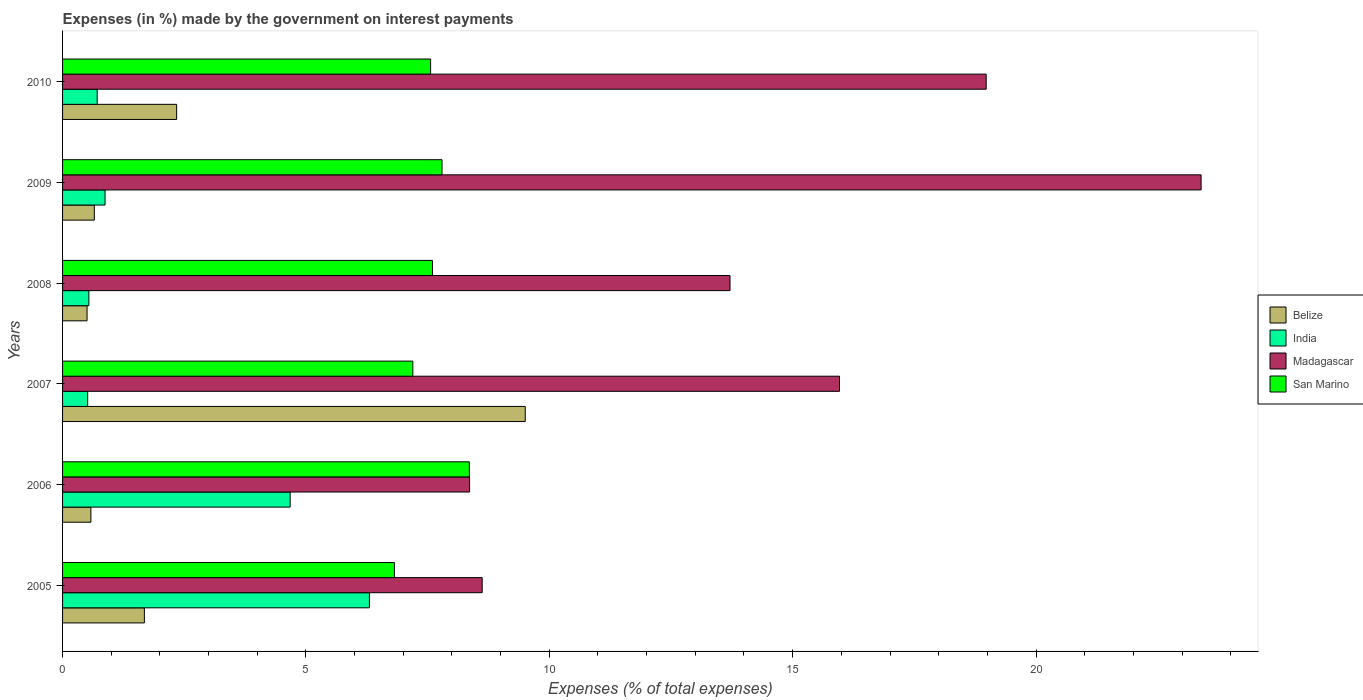How many different coloured bars are there?
Ensure brevity in your answer.  4. How many groups of bars are there?
Make the answer very short. 6. How many bars are there on the 3rd tick from the top?
Offer a very short reply. 4. How many bars are there on the 4th tick from the bottom?
Your answer should be very brief. 4. What is the percentage of expenses made by the government on interest payments in Belize in 2007?
Give a very brief answer. 9.51. Across all years, what is the maximum percentage of expenses made by the government on interest payments in Belize?
Provide a short and direct response. 9.51. Across all years, what is the minimum percentage of expenses made by the government on interest payments in San Marino?
Offer a very short reply. 6.82. In which year was the percentage of expenses made by the government on interest payments in India maximum?
Provide a succinct answer. 2005. What is the total percentage of expenses made by the government on interest payments in Belize in the graph?
Make the answer very short. 15.27. What is the difference between the percentage of expenses made by the government on interest payments in Madagascar in 2005 and that in 2010?
Make the answer very short. -10.36. What is the difference between the percentage of expenses made by the government on interest payments in India in 2005 and the percentage of expenses made by the government on interest payments in San Marino in 2009?
Keep it short and to the point. -1.49. What is the average percentage of expenses made by the government on interest payments in Madagascar per year?
Provide a short and direct response. 14.84. In the year 2006, what is the difference between the percentage of expenses made by the government on interest payments in Madagascar and percentage of expenses made by the government on interest payments in Belize?
Provide a short and direct response. 7.78. In how many years, is the percentage of expenses made by the government on interest payments in Belize greater than 4 %?
Give a very brief answer. 1. What is the ratio of the percentage of expenses made by the government on interest payments in San Marino in 2005 to that in 2010?
Offer a terse response. 0.9. Is the percentage of expenses made by the government on interest payments in India in 2006 less than that in 2008?
Your answer should be very brief. No. What is the difference between the highest and the second highest percentage of expenses made by the government on interest payments in India?
Offer a very short reply. 1.63. What is the difference between the highest and the lowest percentage of expenses made by the government on interest payments in India?
Give a very brief answer. 5.79. In how many years, is the percentage of expenses made by the government on interest payments in San Marino greater than the average percentage of expenses made by the government on interest payments in San Marino taken over all years?
Provide a short and direct response. 4. What does the 1st bar from the top in 2005 represents?
Make the answer very short. San Marino. Is it the case that in every year, the sum of the percentage of expenses made by the government on interest payments in San Marino and percentage of expenses made by the government on interest payments in Belize is greater than the percentage of expenses made by the government on interest payments in Madagascar?
Your answer should be very brief. No. Are all the bars in the graph horizontal?
Keep it short and to the point. Yes. How many years are there in the graph?
Offer a very short reply. 6. What is the difference between two consecutive major ticks on the X-axis?
Make the answer very short. 5. Are the values on the major ticks of X-axis written in scientific E-notation?
Give a very brief answer. No. Does the graph contain grids?
Your response must be concise. No. How many legend labels are there?
Provide a short and direct response. 4. What is the title of the graph?
Provide a short and direct response. Expenses (in %) made by the government on interest payments. What is the label or title of the X-axis?
Keep it short and to the point. Expenses (% of total expenses). What is the Expenses (% of total expenses) in Belize in 2005?
Offer a terse response. 1.68. What is the Expenses (% of total expenses) in India in 2005?
Make the answer very short. 6.3. What is the Expenses (% of total expenses) of Madagascar in 2005?
Make the answer very short. 8.62. What is the Expenses (% of total expenses) of San Marino in 2005?
Make the answer very short. 6.82. What is the Expenses (% of total expenses) in Belize in 2006?
Offer a terse response. 0.58. What is the Expenses (% of total expenses) of India in 2006?
Your answer should be very brief. 4.68. What is the Expenses (% of total expenses) of Madagascar in 2006?
Provide a short and direct response. 8.36. What is the Expenses (% of total expenses) in San Marino in 2006?
Offer a terse response. 8.36. What is the Expenses (% of total expenses) of Belize in 2007?
Give a very brief answer. 9.51. What is the Expenses (% of total expenses) of India in 2007?
Offer a terse response. 0.52. What is the Expenses (% of total expenses) of Madagascar in 2007?
Make the answer very short. 15.96. What is the Expenses (% of total expenses) of San Marino in 2007?
Your answer should be compact. 7.2. What is the Expenses (% of total expenses) in Belize in 2008?
Your answer should be very brief. 0.5. What is the Expenses (% of total expenses) in India in 2008?
Offer a very short reply. 0.54. What is the Expenses (% of total expenses) in Madagascar in 2008?
Your response must be concise. 13.71. What is the Expenses (% of total expenses) of San Marino in 2008?
Provide a succinct answer. 7.6. What is the Expenses (% of total expenses) of Belize in 2009?
Ensure brevity in your answer.  0.65. What is the Expenses (% of total expenses) in India in 2009?
Ensure brevity in your answer.  0.87. What is the Expenses (% of total expenses) of Madagascar in 2009?
Provide a succinct answer. 23.39. What is the Expenses (% of total expenses) of San Marino in 2009?
Offer a very short reply. 7.8. What is the Expenses (% of total expenses) in Belize in 2010?
Provide a succinct answer. 2.34. What is the Expenses (% of total expenses) in India in 2010?
Provide a short and direct response. 0.71. What is the Expenses (% of total expenses) in Madagascar in 2010?
Provide a succinct answer. 18.98. What is the Expenses (% of total expenses) in San Marino in 2010?
Keep it short and to the point. 7.56. Across all years, what is the maximum Expenses (% of total expenses) in Belize?
Give a very brief answer. 9.51. Across all years, what is the maximum Expenses (% of total expenses) in India?
Give a very brief answer. 6.3. Across all years, what is the maximum Expenses (% of total expenses) in Madagascar?
Make the answer very short. 23.39. Across all years, what is the maximum Expenses (% of total expenses) in San Marino?
Provide a short and direct response. 8.36. Across all years, what is the minimum Expenses (% of total expenses) in Belize?
Offer a very short reply. 0.5. Across all years, what is the minimum Expenses (% of total expenses) in India?
Your response must be concise. 0.52. Across all years, what is the minimum Expenses (% of total expenses) in Madagascar?
Offer a very short reply. 8.36. Across all years, what is the minimum Expenses (% of total expenses) in San Marino?
Your answer should be compact. 6.82. What is the total Expenses (% of total expenses) of Belize in the graph?
Provide a succinct answer. 15.27. What is the total Expenses (% of total expenses) in India in the graph?
Provide a short and direct response. 13.62. What is the total Expenses (% of total expenses) of Madagascar in the graph?
Make the answer very short. 89.03. What is the total Expenses (% of total expenses) in San Marino in the graph?
Ensure brevity in your answer.  45.33. What is the difference between the Expenses (% of total expenses) of Belize in 2005 and that in 2006?
Your answer should be compact. 1.1. What is the difference between the Expenses (% of total expenses) of India in 2005 and that in 2006?
Your response must be concise. 1.63. What is the difference between the Expenses (% of total expenses) of Madagascar in 2005 and that in 2006?
Offer a terse response. 0.26. What is the difference between the Expenses (% of total expenses) of San Marino in 2005 and that in 2006?
Ensure brevity in your answer.  -1.54. What is the difference between the Expenses (% of total expenses) in Belize in 2005 and that in 2007?
Offer a terse response. -7.83. What is the difference between the Expenses (% of total expenses) in India in 2005 and that in 2007?
Your answer should be compact. 5.79. What is the difference between the Expenses (% of total expenses) in Madagascar in 2005 and that in 2007?
Give a very brief answer. -7.34. What is the difference between the Expenses (% of total expenses) of San Marino in 2005 and that in 2007?
Offer a very short reply. -0.38. What is the difference between the Expenses (% of total expenses) of Belize in 2005 and that in 2008?
Provide a succinct answer. 1.18. What is the difference between the Expenses (% of total expenses) of India in 2005 and that in 2008?
Offer a very short reply. 5.76. What is the difference between the Expenses (% of total expenses) of Madagascar in 2005 and that in 2008?
Ensure brevity in your answer.  -5.09. What is the difference between the Expenses (% of total expenses) of San Marino in 2005 and that in 2008?
Your answer should be very brief. -0.78. What is the difference between the Expenses (% of total expenses) of Belize in 2005 and that in 2009?
Offer a terse response. 1.03. What is the difference between the Expenses (% of total expenses) of India in 2005 and that in 2009?
Provide a succinct answer. 5.43. What is the difference between the Expenses (% of total expenses) in Madagascar in 2005 and that in 2009?
Ensure brevity in your answer.  -14.77. What is the difference between the Expenses (% of total expenses) in San Marino in 2005 and that in 2009?
Provide a short and direct response. -0.98. What is the difference between the Expenses (% of total expenses) of Belize in 2005 and that in 2010?
Ensure brevity in your answer.  -0.66. What is the difference between the Expenses (% of total expenses) of India in 2005 and that in 2010?
Offer a terse response. 5.59. What is the difference between the Expenses (% of total expenses) in Madagascar in 2005 and that in 2010?
Ensure brevity in your answer.  -10.36. What is the difference between the Expenses (% of total expenses) in San Marino in 2005 and that in 2010?
Keep it short and to the point. -0.74. What is the difference between the Expenses (% of total expenses) of Belize in 2006 and that in 2007?
Your answer should be very brief. -8.92. What is the difference between the Expenses (% of total expenses) of India in 2006 and that in 2007?
Your answer should be very brief. 4.16. What is the difference between the Expenses (% of total expenses) of Madagascar in 2006 and that in 2007?
Offer a terse response. -7.6. What is the difference between the Expenses (% of total expenses) of San Marino in 2006 and that in 2007?
Make the answer very short. 1.16. What is the difference between the Expenses (% of total expenses) in Belize in 2006 and that in 2008?
Provide a succinct answer. 0.08. What is the difference between the Expenses (% of total expenses) of India in 2006 and that in 2008?
Ensure brevity in your answer.  4.14. What is the difference between the Expenses (% of total expenses) of Madagascar in 2006 and that in 2008?
Give a very brief answer. -5.35. What is the difference between the Expenses (% of total expenses) in San Marino in 2006 and that in 2008?
Your answer should be very brief. 0.76. What is the difference between the Expenses (% of total expenses) in Belize in 2006 and that in 2009?
Provide a succinct answer. -0.07. What is the difference between the Expenses (% of total expenses) of India in 2006 and that in 2009?
Your answer should be very brief. 3.8. What is the difference between the Expenses (% of total expenses) in Madagascar in 2006 and that in 2009?
Ensure brevity in your answer.  -15.03. What is the difference between the Expenses (% of total expenses) of San Marino in 2006 and that in 2009?
Your answer should be compact. 0.56. What is the difference between the Expenses (% of total expenses) in Belize in 2006 and that in 2010?
Your response must be concise. -1.76. What is the difference between the Expenses (% of total expenses) in India in 2006 and that in 2010?
Offer a terse response. 3.96. What is the difference between the Expenses (% of total expenses) in Madagascar in 2006 and that in 2010?
Provide a succinct answer. -10.61. What is the difference between the Expenses (% of total expenses) in San Marino in 2006 and that in 2010?
Your answer should be compact. 0.8. What is the difference between the Expenses (% of total expenses) of Belize in 2007 and that in 2008?
Give a very brief answer. 9. What is the difference between the Expenses (% of total expenses) of India in 2007 and that in 2008?
Your answer should be compact. -0.02. What is the difference between the Expenses (% of total expenses) in Madagascar in 2007 and that in 2008?
Offer a very short reply. 2.25. What is the difference between the Expenses (% of total expenses) of San Marino in 2007 and that in 2008?
Provide a succinct answer. -0.4. What is the difference between the Expenses (% of total expenses) in Belize in 2007 and that in 2009?
Your response must be concise. 8.85. What is the difference between the Expenses (% of total expenses) in India in 2007 and that in 2009?
Ensure brevity in your answer.  -0.36. What is the difference between the Expenses (% of total expenses) in Madagascar in 2007 and that in 2009?
Ensure brevity in your answer.  -7.43. What is the difference between the Expenses (% of total expenses) in San Marino in 2007 and that in 2009?
Offer a very short reply. -0.6. What is the difference between the Expenses (% of total expenses) in Belize in 2007 and that in 2010?
Offer a very short reply. 7.16. What is the difference between the Expenses (% of total expenses) of India in 2007 and that in 2010?
Ensure brevity in your answer.  -0.2. What is the difference between the Expenses (% of total expenses) of Madagascar in 2007 and that in 2010?
Offer a terse response. -3.01. What is the difference between the Expenses (% of total expenses) in San Marino in 2007 and that in 2010?
Keep it short and to the point. -0.37. What is the difference between the Expenses (% of total expenses) of Belize in 2008 and that in 2009?
Keep it short and to the point. -0.15. What is the difference between the Expenses (% of total expenses) of India in 2008 and that in 2009?
Your answer should be very brief. -0.33. What is the difference between the Expenses (% of total expenses) of Madagascar in 2008 and that in 2009?
Offer a terse response. -9.68. What is the difference between the Expenses (% of total expenses) of San Marino in 2008 and that in 2009?
Offer a terse response. -0.2. What is the difference between the Expenses (% of total expenses) of Belize in 2008 and that in 2010?
Keep it short and to the point. -1.84. What is the difference between the Expenses (% of total expenses) of India in 2008 and that in 2010?
Your answer should be compact. -0.17. What is the difference between the Expenses (% of total expenses) in Madagascar in 2008 and that in 2010?
Your answer should be very brief. -5.26. What is the difference between the Expenses (% of total expenses) of San Marino in 2008 and that in 2010?
Offer a very short reply. 0.04. What is the difference between the Expenses (% of total expenses) in Belize in 2009 and that in 2010?
Give a very brief answer. -1.69. What is the difference between the Expenses (% of total expenses) of India in 2009 and that in 2010?
Ensure brevity in your answer.  0.16. What is the difference between the Expenses (% of total expenses) of Madagascar in 2009 and that in 2010?
Provide a short and direct response. 4.42. What is the difference between the Expenses (% of total expenses) of San Marino in 2009 and that in 2010?
Provide a succinct answer. 0.23. What is the difference between the Expenses (% of total expenses) in Belize in 2005 and the Expenses (% of total expenses) in India in 2006?
Offer a terse response. -3. What is the difference between the Expenses (% of total expenses) in Belize in 2005 and the Expenses (% of total expenses) in Madagascar in 2006?
Offer a terse response. -6.68. What is the difference between the Expenses (% of total expenses) in Belize in 2005 and the Expenses (% of total expenses) in San Marino in 2006?
Offer a terse response. -6.68. What is the difference between the Expenses (% of total expenses) in India in 2005 and the Expenses (% of total expenses) in Madagascar in 2006?
Ensure brevity in your answer.  -2.06. What is the difference between the Expenses (% of total expenses) of India in 2005 and the Expenses (% of total expenses) of San Marino in 2006?
Your answer should be compact. -2.05. What is the difference between the Expenses (% of total expenses) of Madagascar in 2005 and the Expenses (% of total expenses) of San Marino in 2006?
Provide a succinct answer. 0.26. What is the difference between the Expenses (% of total expenses) of Belize in 2005 and the Expenses (% of total expenses) of India in 2007?
Make the answer very short. 1.16. What is the difference between the Expenses (% of total expenses) of Belize in 2005 and the Expenses (% of total expenses) of Madagascar in 2007?
Your response must be concise. -14.28. What is the difference between the Expenses (% of total expenses) of Belize in 2005 and the Expenses (% of total expenses) of San Marino in 2007?
Give a very brief answer. -5.52. What is the difference between the Expenses (% of total expenses) in India in 2005 and the Expenses (% of total expenses) in Madagascar in 2007?
Your answer should be compact. -9.66. What is the difference between the Expenses (% of total expenses) of India in 2005 and the Expenses (% of total expenses) of San Marino in 2007?
Keep it short and to the point. -0.89. What is the difference between the Expenses (% of total expenses) in Madagascar in 2005 and the Expenses (% of total expenses) in San Marino in 2007?
Provide a succinct answer. 1.42. What is the difference between the Expenses (% of total expenses) in Belize in 2005 and the Expenses (% of total expenses) in India in 2008?
Your answer should be compact. 1.14. What is the difference between the Expenses (% of total expenses) of Belize in 2005 and the Expenses (% of total expenses) of Madagascar in 2008?
Offer a terse response. -12.03. What is the difference between the Expenses (% of total expenses) in Belize in 2005 and the Expenses (% of total expenses) in San Marino in 2008?
Make the answer very short. -5.92. What is the difference between the Expenses (% of total expenses) in India in 2005 and the Expenses (% of total expenses) in Madagascar in 2008?
Offer a very short reply. -7.41. What is the difference between the Expenses (% of total expenses) in India in 2005 and the Expenses (% of total expenses) in San Marino in 2008?
Offer a very short reply. -1.29. What is the difference between the Expenses (% of total expenses) in Madagascar in 2005 and the Expenses (% of total expenses) in San Marino in 2008?
Provide a short and direct response. 1.02. What is the difference between the Expenses (% of total expenses) of Belize in 2005 and the Expenses (% of total expenses) of India in 2009?
Provide a succinct answer. 0.81. What is the difference between the Expenses (% of total expenses) of Belize in 2005 and the Expenses (% of total expenses) of Madagascar in 2009?
Offer a terse response. -21.71. What is the difference between the Expenses (% of total expenses) of Belize in 2005 and the Expenses (% of total expenses) of San Marino in 2009?
Ensure brevity in your answer.  -6.12. What is the difference between the Expenses (% of total expenses) of India in 2005 and the Expenses (% of total expenses) of Madagascar in 2009?
Offer a very short reply. -17.09. What is the difference between the Expenses (% of total expenses) in India in 2005 and the Expenses (% of total expenses) in San Marino in 2009?
Provide a short and direct response. -1.49. What is the difference between the Expenses (% of total expenses) of Madagascar in 2005 and the Expenses (% of total expenses) of San Marino in 2009?
Ensure brevity in your answer.  0.82. What is the difference between the Expenses (% of total expenses) of Belize in 2005 and the Expenses (% of total expenses) of India in 2010?
Your response must be concise. 0.97. What is the difference between the Expenses (% of total expenses) of Belize in 2005 and the Expenses (% of total expenses) of Madagascar in 2010?
Offer a terse response. -17.3. What is the difference between the Expenses (% of total expenses) in Belize in 2005 and the Expenses (% of total expenses) in San Marino in 2010?
Keep it short and to the point. -5.88. What is the difference between the Expenses (% of total expenses) in India in 2005 and the Expenses (% of total expenses) in Madagascar in 2010?
Offer a very short reply. -12.67. What is the difference between the Expenses (% of total expenses) of India in 2005 and the Expenses (% of total expenses) of San Marino in 2010?
Your answer should be very brief. -1.26. What is the difference between the Expenses (% of total expenses) in Madagascar in 2005 and the Expenses (% of total expenses) in San Marino in 2010?
Ensure brevity in your answer.  1.06. What is the difference between the Expenses (% of total expenses) of Belize in 2006 and the Expenses (% of total expenses) of India in 2007?
Give a very brief answer. 0.07. What is the difference between the Expenses (% of total expenses) in Belize in 2006 and the Expenses (% of total expenses) in Madagascar in 2007?
Provide a succinct answer. -15.38. What is the difference between the Expenses (% of total expenses) of Belize in 2006 and the Expenses (% of total expenses) of San Marino in 2007?
Ensure brevity in your answer.  -6.61. What is the difference between the Expenses (% of total expenses) in India in 2006 and the Expenses (% of total expenses) in Madagascar in 2007?
Ensure brevity in your answer.  -11.29. What is the difference between the Expenses (% of total expenses) in India in 2006 and the Expenses (% of total expenses) in San Marino in 2007?
Your answer should be compact. -2.52. What is the difference between the Expenses (% of total expenses) of Madagascar in 2006 and the Expenses (% of total expenses) of San Marino in 2007?
Provide a succinct answer. 1.17. What is the difference between the Expenses (% of total expenses) in Belize in 2006 and the Expenses (% of total expenses) in India in 2008?
Your answer should be compact. 0.04. What is the difference between the Expenses (% of total expenses) of Belize in 2006 and the Expenses (% of total expenses) of Madagascar in 2008?
Your response must be concise. -13.13. What is the difference between the Expenses (% of total expenses) of Belize in 2006 and the Expenses (% of total expenses) of San Marino in 2008?
Offer a terse response. -7.02. What is the difference between the Expenses (% of total expenses) of India in 2006 and the Expenses (% of total expenses) of Madagascar in 2008?
Offer a very short reply. -9.04. What is the difference between the Expenses (% of total expenses) in India in 2006 and the Expenses (% of total expenses) in San Marino in 2008?
Make the answer very short. -2.92. What is the difference between the Expenses (% of total expenses) in Madagascar in 2006 and the Expenses (% of total expenses) in San Marino in 2008?
Ensure brevity in your answer.  0.76. What is the difference between the Expenses (% of total expenses) of Belize in 2006 and the Expenses (% of total expenses) of India in 2009?
Make the answer very short. -0.29. What is the difference between the Expenses (% of total expenses) of Belize in 2006 and the Expenses (% of total expenses) of Madagascar in 2009?
Your answer should be very brief. -22.81. What is the difference between the Expenses (% of total expenses) in Belize in 2006 and the Expenses (% of total expenses) in San Marino in 2009?
Offer a terse response. -7.21. What is the difference between the Expenses (% of total expenses) of India in 2006 and the Expenses (% of total expenses) of Madagascar in 2009?
Ensure brevity in your answer.  -18.72. What is the difference between the Expenses (% of total expenses) of India in 2006 and the Expenses (% of total expenses) of San Marino in 2009?
Your response must be concise. -3.12. What is the difference between the Expenses (% of total expenses) in Madagascar in 2006 and the Expenses (% of total expenses) in San Marino in 2009?
Offer a very short reply. 0.57. What is the difference between the Expenses (% of total expenses) in Belize in 2006 and the Expenses (% of total expenses) in India in 2010?
Provide a short and direct response. -0.13. What is the difference between the Expenses (% of total expenses) in Belize in 2006 and the Expenses (% of total expenses) in Madagascar in 2010?
Offer a terse response. -18.39. What is the difference between the Expenses (% of total expenses) in Belize in 2006 and the Expenses (% of total expenses) in San Marino in 2010?
Offer a terse response. -6.98. What is the difference between the Expenses (% of total expenses) in India in 2006 and the Expenses (% of total expenses) in Madagascar in 2010?
Offer a terse response. -14.3. What is the difference between the Expenses (% of total expenses) of India in 2006 and the Expenses (% of total expenses) of San Marino in 2010?
Ensure brevity in your answer.  -2.89. What is the difference between the Expenses (% of total expenses) of Madagascar in 2006 and the Expenses (% of total expenses) of San Marino in 2010?
Provide a succinct answer. 0.8. What is the difference between the Expenses (% of total expenses) in Belize in 2007 and the Expenses (% of total expenses) in India in 2008?
Give a very brief answer. 8.97. What is the difference between the Expenses (% of total expenses) of Belize in 2007 and the Expenses (% of total expenses) of Madagascar in 2008?
Give a very brief answer. -4.21. What is the difference between the Expenses (% of total expenses) in Belize in 2007 and the Expenses (% of total expenses) in San Marino in 2008?
Your answer should be very brief. 1.91. What is the difference between the Expenses (% of total expenses) of India in 2007 and the Expenses (% of total expenses) of Madagascar in 2008?
Offer a very short reply. -13.2. What is the difference between the Expenses (% of total expenses) in India in 2007 and the Expenses (% of total expenses) in San Marino in 2008?
Offer a terse response. -7.08. What is the difference between the Expenses (% of total expenses) of Madagascar in 2007 and the Expenses (% of total expenses) of San Marino in 2008?
Ensure brevity in your answer.  8.36. What is the difference between the Expenses (% of total expenses) in Belize in 2007 and the Expenses (% of total expenses) in India in 2009?
Keep it short and to the point. 8.63. What is the difference between the Expenses (% of total expenses) of Belize in 2007 and the Expenses (% of total expenses) of Madagascar in 2009?
Provide a short and direct response. -13.89. What is the difference between the Expenses (% of total expenses) of Belize in 2007 and the Expenses (% of total expenses) of San Marino in 2009?
Offer a very short reply. 1.71. What is the difference between the Expenses (% of total expenses) in India in 2007 and the Expenses (% of total expenses) in Madagascar in 2009?
Provide a succinct answer. -22.88. What is the difference between the Expenses (% of total expenses) in India in 2007 and the Expenses (% of total expenses) in San Marino in 2009?
Your answer should be very brief. -7.28. What is the difference between the Expenses (% of total expenses) of Madagascar in 2007 and the Expenses (% of total expenses) of San Marino in 2009?
Provide a short and direct response. 8.17. What is the difference between the Expenses (% of total expenses) in Belize in 2007 and the Expenses (% of total expenses) in India in 2010?
Ensure brevity in your answer.  8.79. What is the difference between the Expenses (% of total expenses) of Belize in 2007 and the Expenses (% of total expenses) of Madagascar in 2010?
Your answer should be compact. -9.47. What is the difference between the Expenses (% of total expenses) of Belize in 2007 and the Expenses (% of total expenses) of San Marino in 2010?
Offer a terse response. 1.94. What is the difference between the Expenses (% of total expenses) of India in 2007 and the Expenses (% of total expenses) of Madagascar in 2010?
Keep it short and to the point. -18.46. What is the difference between the Expenses (% of total expenses) of India in 2007 and the Expenses (% of total expenses) of San Marino in 2010?
Keep it short and to the point. -7.05. What is the difference between the Expenses (% of total expenses) in Madagascar in 2007 and the Expenses (% of total expenses) in San Marino in 2010?
Ensure brevity in your answer.  8.4. What is the difference between the Expenses (% of total expenses) of Belize in 2008 and the Expenses (% of total expenses) of India in 2009?
Give a very brief answer. -0.37. What is the difference between the Expenses (% of total expenses) of Belize in 2008 and the Expenses (% of total expenses) of Madagascar in 2009?
Make the answer very short. -22.89. What is the difference between the Expenses (% of total expenses) of Belize in 2008 and the Expenses (% of total expenses) of San Marino in 2009?
Offer a very short reply. -7.29. What is the difference between the Expenses (% of total expenses) of India in 2008 and the Expenses (% of total expenses) of Madagascar in 2009?
Your answer should be compact. -22.85. What is the difference between the Expenses (% of total expenses) of India in 2008 and the Expenses (% of total expenses) of San Marino in 2009?
Your answer should be very brief. -7.26. What is the difference between the Expenses (% of total expenses) of Madagascar in 2008 and the Expenses (% of total expenses) of San Marino in 2009?
Your answer should be very brief. 5.92. What is the difference between the Expenses (% of total expenses) in Belize in 2008 and the Expenses (% of total expenses) in India in 2010?
Keep it short and to the point. -0.21. What is the difference between the Expenses (% of total expenses) of Belize in 2008 and the Expenses (% of total expenses) of Madagascar in 2010?
Your response must be concise. -18.47. What is the difference between the Expenses (% of total expenses) of Belize in 2008 and the Expenses (% of total expenses) of San Marino in 2010?
Your answer should be very brief. -7.06. What is the difference between the Expenses (% of total expenses) of India in 2008 and the Expenses (% of total expenses) of Madagascar in 2010?
Your answer should be very brief. -18.44. What is the difference between the Expenses (% of total expenses) in India in 2008 and the Expenses (% of total expenses) in San Marino in 2010?
Give a very brief answer. -7.02. What is the difference between the Expenses (% of total expenses) in Madagascar in 2008 and the Expenses (% of total expenses) in San Marino in 2010?
Offer a terse response. 6.15. What is the difference between the Expenses (% of total expenses) of Belize in 2009 and the Expenses (% of total expenses) of India in 2010?
Your answer should be compact. -0.06. What is the difference between the Expenses (% of total expenses) of Belize in 2009 and the Expenses (% of total expenses) of Madagascar in 2010?
Provide a succinct answer. -18.32. What is the difference between the Expenses (% of total expenses) of Belize in 2009 and the Expenses (% of total expenses) of San Marino in 2010?
Provide a succinct answer. -6.91. What is the difference between the Expenses (% of total expenses) of India in 2009 and the Expenses (% of total expenses) of Madagascar in 2010?
Offer a very short reply. -18.1. What is the difference between the Expenses (% of total expenses) of India in 2009 and the Expenses (% of total expenses) of San Marino in 2010?
Give a very brief answer. -6.69. What is the difference between the Expenses (% of total expenses) of Madagascar in 2009 and the Expenses (% of total expenses) of San Marino in 2010?
Give a very brief answer. 15.83. What is the average Expenses (% of total expenses) in Belize per year?
Provide a succinct answer. 2.54. What is the average Expenses (% of total expenses) in India per year?
Offer a terse response. 2.27. What is the average Expenses (% of total expenses) of Madagascar per year?
Your response must be concise. 14.84. What is the average Expenses (% of total expenses) of San Marino per year?
Your answer should be very brief. 7.55. In the year 2005, what is the difference between the Expenses (% of total expenses) of Belize and Expenses (% of total expenses) of India?
Ensure brevity in your answer.  -4.62. In the year 2005, what is the difference between the Expenses (% of total expenses) of Belize and Expenses (% of total expenses) of Madagascar?
Offer a terse response. -6.94. In the year 2005, what is the difference between the Expenses (% of total expenses) of Belize and Expenses (% of total expenses) of San Marino?
Keep it short and to the point. -5.14. In the year 2005, what is the difference between the Expenses (% of total expenses) in India and Expenses (% of total expenses) in Madagascar?
Your answer should be compact. -2.32. In the year 2005, what is the difference between the Expenses (% of total expenses) in India and Expenses (% of total expenses) in San Marino?
Offer a very short reply. -0.51. In the year 2005, what is the difference between the Expenses (% of total expenses) in Madagascar and Expenses (% of total expenses) in San Marino?
Offer a very short reply. 1.8. In the year 2006, what is the difference between the Expenses (% of total expenses) in Belize and Expenses (% of total expenses) in India?
Your answer should be compact. -4.09. In the year 2006, what is the difference between the Expenses (% of total expenses) in Belize and Expenses (% of total expenses) in Madagascar?
Give a very brief answer. -7.78. In the year 2006, what is the difference between the Expenses (% of total expenses) of Belize and Expenses (% of total expenses) of San Marino?
Your answer should be very brief. -7.78. In the year 2006, what is the difference between the Expenses (% of total expenses) of India and Expenses (% of total expenses) of Madagascar?
Your answer should be compact. -3.69. In the year 2006, what is the difference between the Expenses (% of total expenses) of India and Expenses (% of total expenses) of San Marino?
Make the answer very short. -3.68. In the year 2006, what is the difference between the Expenses (% of total expenses) of Madagascar and Expenses (% of total expenses) of San Marino?
Give a very brief answer. 0. In the year 2007, what is the difference between the Expenses (% of total expenses) in Belize and Expenses (% of total expenses) in India?
Your response must be concise. 8.99. In the year 2007, what is the difference between the Expenses (% of total expenses) of Belize and Expenses (% of total expenses) of Madagascar?
Give a very brief answer. -6.46. In the year 2007, what is the difference between the Expenses (% of total expenses) of Belize and Expenses (% of total expenses) of San Marino?
Keep it short and to the point. 2.31. In the year 2007, what is the difference between the Expenses (% of total expenses) in India and Expenses (% of total expenses) in Madagascar?
Provide a succinct answer. -15.45. In the year 2007, what is the difference between the Expenses (% of total expenses) in India and Expenses (% of total expenses) in San Marino?
Ensure brevity in your answer.  -6.68. In the year 2007, what is the difference between the Expenses (% of total expenses) in Madagascar and Expenses (% of total expenses) in San Marino?
Your answer should be compact. 8.77. In the year 2008, what is the difference between the Expenses (% of total expenses) in Belize and Expenses (% of total expenses) in India?
Your response must be concise. -0.04. In the year 2008, what is the difference between the Expenses (% of total expenses) of Belize and Expenses (% of total expenses) of Madagascar?
Keep it short and to the point. -13.21. In the year 2008, what is the difference between the Expenses (% of total expenses) in Belize and Expenses (% of total expenses) in San Marino?
Provide a succinct answer. -7.1. In the year 2008, what is the difference between the Expenses (% of total expenses) in India and Expenses (% of total expenses) in Madagascar?
Your response must be concise. -13.17. In the year 2008, what is the difference between the Expenses (% of total expenses) of India and Expenses (% of total expenses) of San Marino?
Provide a short and direct response. -7.06. In the year 2008, what is the difference between the Expenses (% of total expenses) of Madagascar and Expenses (% of total expenses) of San Marino?
Keep it short and to the point. 6.11. In the year 2009, what is the difference between the Expenses (% of total expenses) of Belize and Expenses (% of total expenses) of India?
Keep it short and to the point. -0.22. In the year 2009, what is the difference between the Expenses (% of total expenses) in Belize and Expenses (% of total expenses) in Madagascar?
Offer a terse response. -22.74. In the year 2009, what is the difference between the Expenses (% of total expenses) of Belize and Expenses (% of total expenses) of San Marino?
Keep it short and to the point. -7.14. In the year 2009, what is the difference between the Expenses (% of total expenses) in India and Expenses (% of total expenses) in Madagascar?
Ensure brevity in your answer.  -22.52. In the year 2009, what is the difference between the Expenses (% of total expenses) of India and Expenses (% of total expenses) of San Marino?
Keep it short and to the point. -6.92. In the year 2009, what is the difference between the Expenses (% of total expenses) in Madagascar and Expenses (% of total expenses) in San Marino?
Your answer should be compact. 15.6. In the year 2010, what is the difference between the Expenses (% of total expenses) of Belize and Expenses (% of total expenses) of India?
Provide a succinct answer. 1.63. In the year 2010, what is the difference between the Expenses (% of total expenses) in Belize and Expenses (% of total expenses) in Madagascar?
Your answer should be compact. -16.63. In the year 2010, what is the difference between the Expenses (% of total expenses) of Belize and Expenses (% of total expenses) of San Marino?
Offer a very short reply. -5.22. In the year 2010, what is the difference between the Expenses (% of total expenses) of India and Expenses (% of total expenses) of Madagascar?
Your answer should be very brief. -18.26. In the year 2010, what is the difference between the Expenses (% of total expenses) in India and Expenses (% of total expenses) in San Marino?
Keep it short and to the point. -6.85. In the year 2010, what is the difference between the Expenses (% of total expenses) of Madagascar and Expenses (% of total expenses) of San Marino?
Keep it short and to the point. 11.41. What is the ratio of the Expenses (% of total expenses) in Belize in 2005 to that in 2006?
Your response must be concise. 2.89. What is the ratio of the Expenses (% of total expenses) in India in 2005 to that in 2006?
Ensure brevity in your answer.  1.35. What is the ratio of the Expenses (% of total expenses) of Madagascar in 2005 to that in 2006?
Keep it short and to the point. 1.03. What is the ratio of the Expenses (% of total expenses) in San Marino in 2005 to that in 2006?
Provide a succinct answer. 0.82. What is the ratio of the Expenses (% of total expenses) of Belize in 2005 to that in 2007?
Provide a short and direct response. 0.18. What is the ratio of the Expenses (% of total expenses) in India in 2005 to that in 2007?
Offer a very short reply. 12.22. What is the ratio of the Expenses (% of total expenses) in Madagascar in 2005 to that in 2007?
Your answer should be very brief. 0.54. What is the ratio of the Expenses (% of total expenses) in San Marino in 2005 to that in 2007?
Keep it short and to the point. 0.95. What is the ratio of the Expenses (% of total expenses) of Belize in 2005 to that in 2008?
Your response must be concise. 3.34. What is the ratio of the Expenses (% of total expenses) of India in 2005 to that in 2008?
Your answer should be compact. 11.67. What is the ratio of the Expenses (% of total expenses) in Madagascar in 2005 to that in 2008?
Provide a short and direct response. 0.63. What is the ratio of the Expenses (% of total expenses) of San Marino in 2005 to that in 2008?
Provide a succinct answer. 0.9. What is the ratio of the Expenses (% of total expenses) of Belize in 2005 to that in 2009?
Your response must be concise. 2.58. What is the ratio of the Expenses (% of total expenses) of India in 2005 to that in 2009?
Your response must be concise. 7.22. What is the ratio of the Expenses (% of total expenses) in Madagascar in 2005 to that in 2009?
Your answer should be compact. 0.37. What is the ratio of the Expenses (% of total expenses) of San Marino in 2005 to that in 2009?
Your response must be concise. 0.87. What is the ratio of the Expenses (% of total expenses) in Belize in 2005 to that in 2010?
Your answer should be compact. 0.72. What is the ratio of the Expenses (% of total expenses) of India in 2005 to that in 2010?
Make the answer very short. 8.86. What is the ratio of the Expenses (% of total expenses) in Madagascar in 2005 to that in 2010?
Make the answer very short. 0.45. What is the ratio of the Expenses (% of total expenses) in San Marino in 2005 to that in 2010?
Your response must be concise. 0.9. What is the ratio of the Expenses (% of total expenses) of Belize in 2006 to that in 2007?
Your response must be concise. 0.06. What is the ratio of the Expenses (% of total expenses) in India in 2006 to that in 2007?
Offer a terse response. 9.07. What is the ratio of the Expenses (% of total expenses) of Madagascar in 2006 to that in 2007?
Keep it short and to the point. 0.52. What is the ratio of the Expenses (% of total expenses) in San Marino in 2006 to that in 2007?
Your answer should be compact. 1.16. What is the ratio of the Expenses (% of total expenses) of Belize in 2006 to that in 2008?
Offer a terse response. 1.16. What is the ratio of the Expenses (% of total expenses) in India in 2006 to that in 2008?
Give a very brief answer. 8.66. What is the ratio of the Expenses (% of total expenses) of Madagascar in 2006 to that in 2008?
Provide a succinct answer. 0.61. What is the ratio of the Expenses (% of total expenses) of San Marino in 2006 to that in 2008?
Give a very brief answer. 1.1. What is the ratio of the Expenses (% of total expenses) of Belize in 2006 to that in 2009?
Keep it short and to the point. 0.89. What is the ratio of the Expenses (% of total expenses) in India in 2006 to that in 2009?
Provide a succinct answer. 5.36. What is the ratio of the Expenses (% of total expenses) in Madagascar in 2006 to that in 2009?
Give a very brief answer. 0.36. What is the ratio of the Expenses (% of total expenses) of San Marino in 2006 to that in 2009?
Offer a terse response. 1.07. What is the ratio of the Expenses (% of total expenses) of Belize in 2006 to that in 2010?
Your response must be concise. 0.25. What is the ratio of the Expenses (% of total expenses) of India in 2006 to that in 2010?
Your response must be concise. 6.57. What is the ratio of the Expenses (% of total expenses) in Madagascar in 2006 to that in 2010?
Offer a terse response. 0.44. What is the ratio of the Expenses (% of total expenses) in San Marino in 2006 to that in 2010?
Your response must be concise. 1.11. What is the ratio of the Expenses (% of total expenses) of Belize in 2007 to that in 2008?
Keep it short and to the point. 18.88. What is the ratio of the Expenses (% of total expenses) in India in 2007 to that in 2008?
Your response must be concise. 0.95. What is the ratio of the Expenses (% of total expenses) in Madagascar in 2007 to that in 2008?
Give a very brief answer. 1.16. What is the ratio of the Expenses (% of total expenses) of San Marino in 2007 to that in 2008?
Keep it short and to the point. 0.95. What is the ratio of the Expenses (% of total expenses) of Belize in 2007 to that in 2009?
Provide a short and direct response. 14.57. What is the ratio of the Expenses (% of total expenses) of India in 2007 to that in 2009?
Your answer should be very brief. 0.59. What is the ratio of the Expenses (% of total expenses) in Madagascar in 2007 to that in 2009?
Make the answer very short. 0.68. What is the ratio of the Expenses (% of total expenses) in San Marino in 2007 to that in 2009?
Keep it short and to the point. 0.92. What is the ratio of the Expenses (% of total expenses) of Belize in 2007 to that in 2010?
Give a very brief answer. 4.06. What is the ratio of the Expenses (% of total expenses) in India in 2007 to that in 2010?
Your answer should be compact. 0.73. What is the ratio of the Expenses (% of total expenses) in Madagascar in 2007 to that in 2010?
Your answer should be very brief. 0.84. What is the ratio of the Expenses (% of total expenses) of San Marino in 2007 to that in 2010?
Ensure brevity in your answer.  0.95. What is the ratio of the Expenses (% of total expenses) of Belize in 2008 to that in 2009?
Ensure brevity in your answer.  0.77. What is the ratio of the Expenses (% of total expenses) in India in 2008 to that in 2009?
Offer a very short reply. 0.62. What is the ratio of the Expenses (% of total expenses) of Madagascar in 2008 to that in 2009?
Provide a short and direct response. 0.59. What is the ratio of the Expenses (% of total expenses) of San Marino in 2008 to that in 2009?
Your response must be concise. 0.97. What is the ratio of the Expenses (% of total expenses) of Belize in 2008 to that in 2010?
Your answer should be compact. 0.21. What is the ratio of the Expenses (% of total expenses) of India in 2008 to that in 2010?
Offer a very short reply. 0.76. What is the ratio of the Expenses (% of total expenses) of Madagascar in 2008 to that in 2010?
Your answer should be very brief. 0.72. What is the ratio of the Expenses (% of total expenses) in Belize in 2009 to that in 2010?
Your answer should be very brief. 0.28. What is the ratio of the Expenses (% of total expenses) in India in 2009 to that in 2010?
Give a very brief answer. 1.23. What is the ratio of the Expenses (% of total expenses) of Madagascar in 2009 to that in 2010?
Make the answer very short. 1.23. What is the ratio of the Expenses (% of total expenses) in San Marino in 2009 to that in 2010?
Your response must be concise. 1.03. What is the difference between the highest and the second highest Expenses (% of total expenses) in Belize?
Make the answer very short. 7.16. What is the difference between the highest and the second highest Expenses (% of total expenses) in India?
Provide a succinct answer. 1.63. What is the difference between the highest and the second highest Expenses (% of total expenses) in Madagascar?
Provide a short and direct response. 4.42. What is the difference between the highest and the second highest Expenses (% of total expenses) in San Marino?
Your answer should be compact. 0.56. What is the difference between the highest and the lowest Expenses (% of total expenses) of Belize?
Keep it short and to the point. 9. What is the difference between the highest and the lowest Expenses (% of total expenses) of India?
Make the answer very short. 5.79. What is the difference between the highest and the lowest Expenses (% of total expenses) of Madagascar?
Your answer should be compact. 15.03. What is the difference between the highest and the lowest Expenses (% of total expenses) in San Marino?
Make the answer very short. 1.54. 